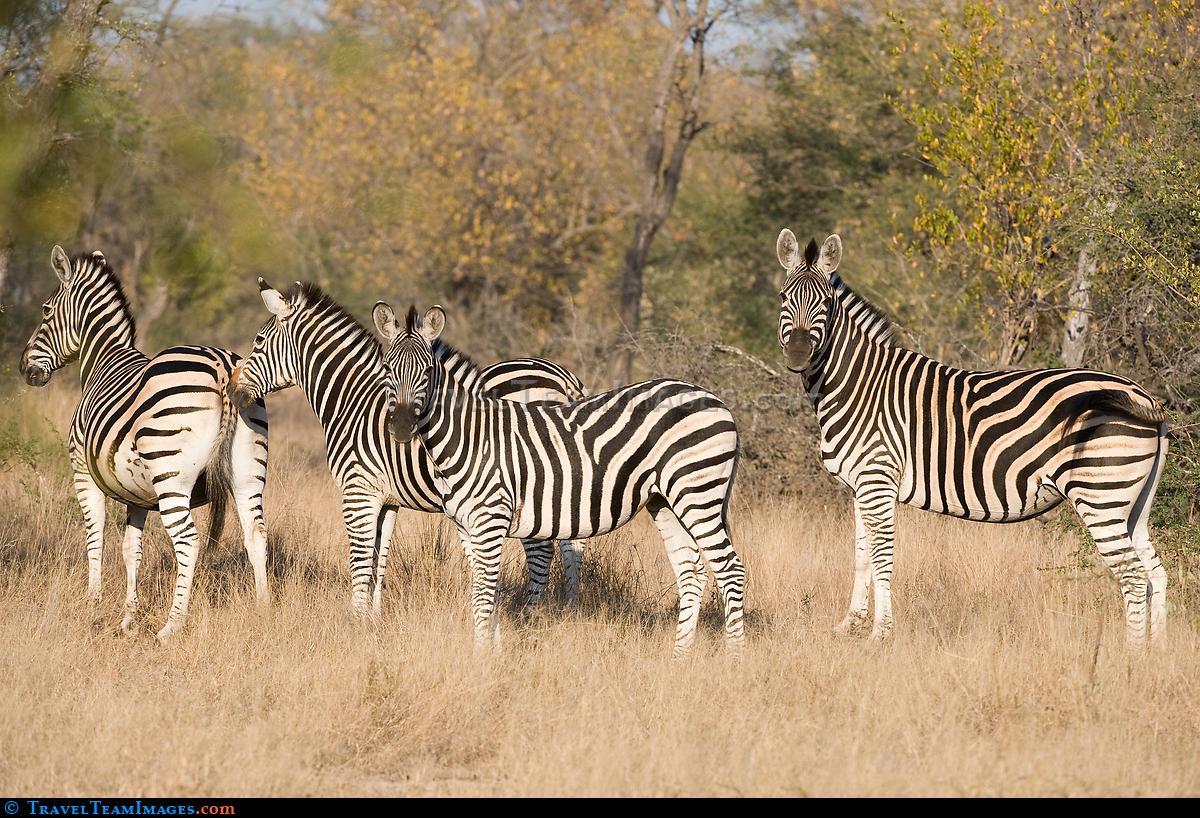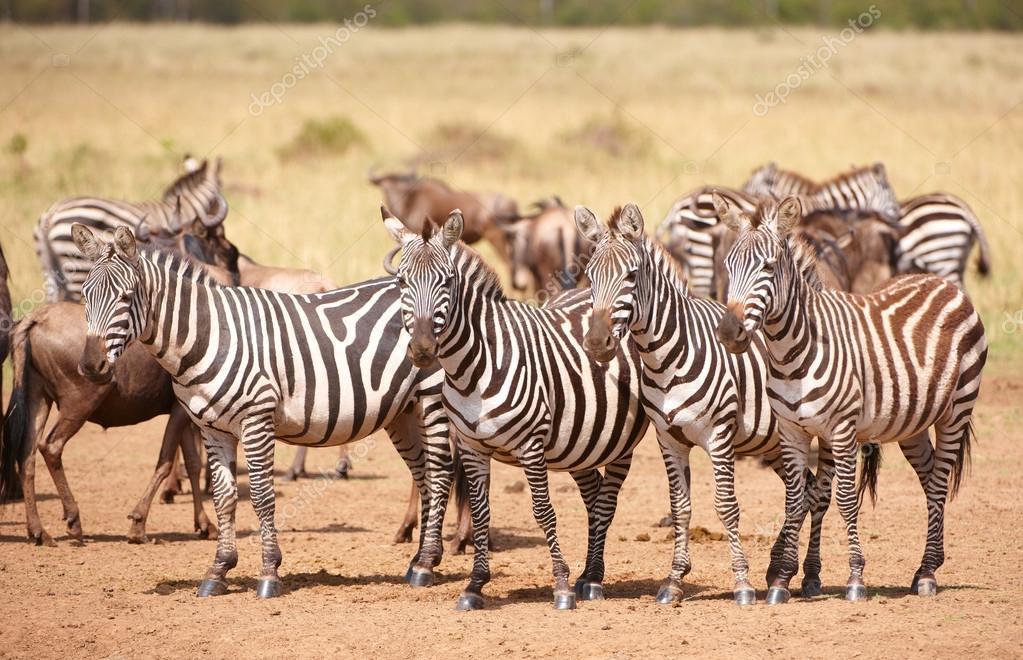The first image is the image on the left, the second image is the image on the right. For the images shown, is this caption "One animal in one of the images is bucking." true? Answer yes or no. No. The first image is the image on the left, the second image is the image on the right. Assess this claim about the two images: "One image shows a herd of zebras in profile all moving toward the right and stirring up the non-grass material under their feet.". Correct or not? Answer yes or no. No. 